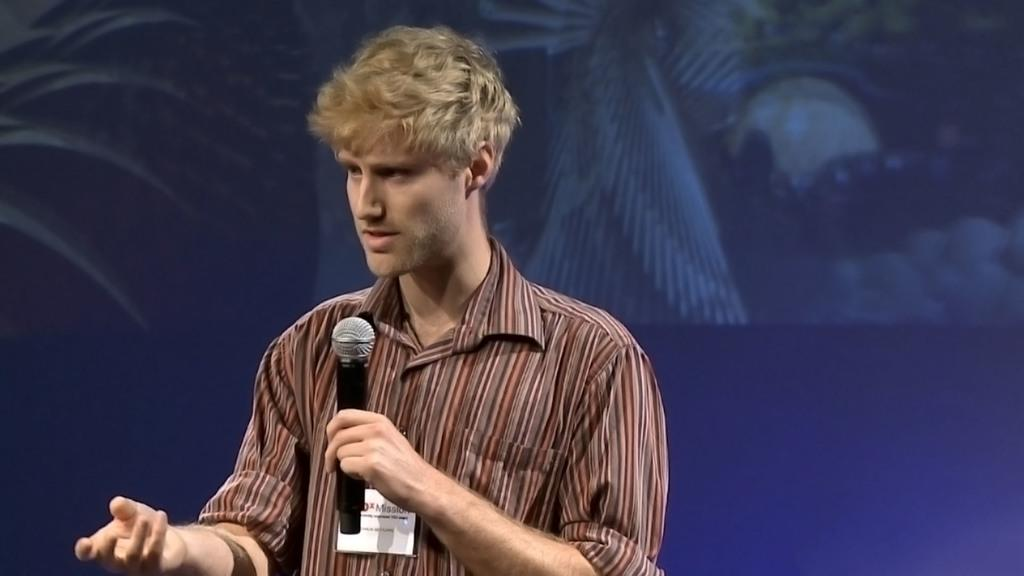What is the main subject of the image? There is a man in the image. Can you describe the man's clothing? The man is wearing a shirt with lines. What is the man doing in the image? The man is standing and holding a mic in his left hand. Is there any additional information about the man's attire? Yes, there is a card attached to the man's shirt. What can be seen in the background of the image? There is a screen with a blue color in the background of the image. What type of nail is being hammered into the road in the image? There is no nail or road present in the image; it features a man holding a mic and standing in front of a screen with a blue color. Is there a cushion visible in the image? No, there is no cushion present in the image. 